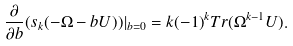<formula> <loc_0><loc_0><loc_500><loc_500>\frac { \partial } { \partial b } ( s _ { k } ( - \Omega - b U ) ) | _ { b = 0 } = k ( - 1 ) ^ { k } T r ( \Omega ^ { k - 1 } U ) .</formula> 